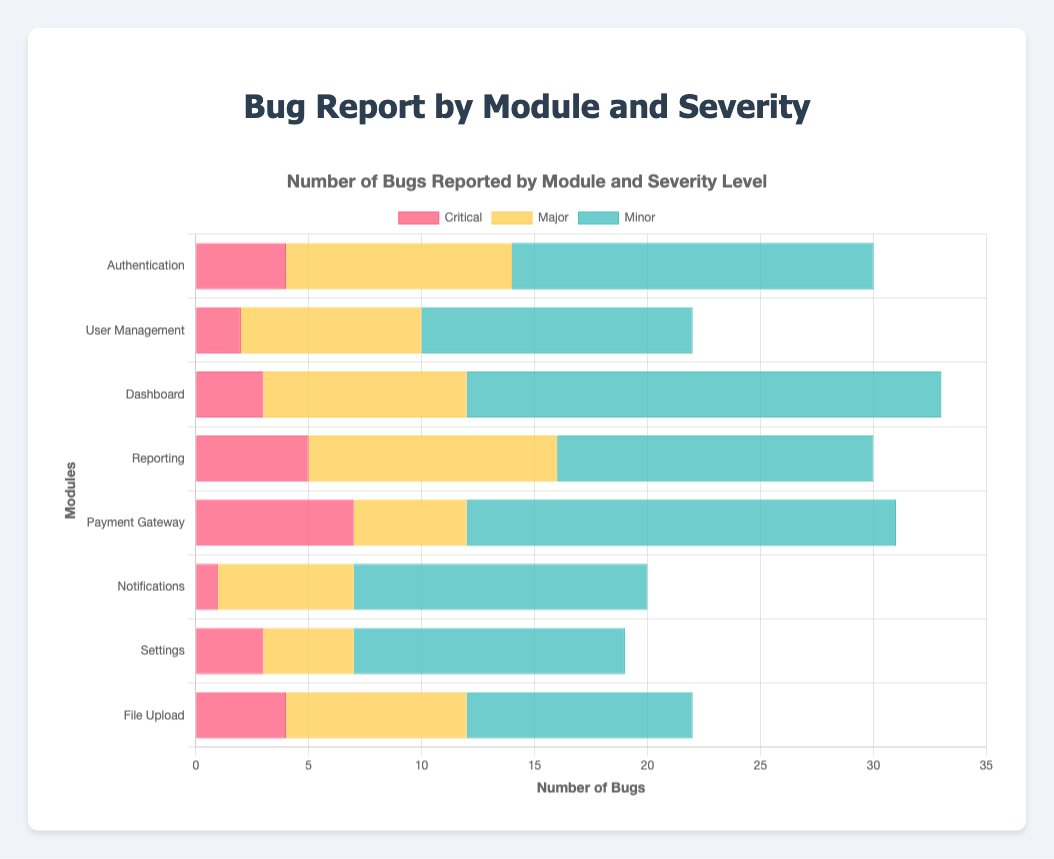What's the total number of critical bugs reported across all modules? To find the total number of critical bugs, sum up the critical bugs from all modules: 4 (Authentication) + 2 (User Management) + 3 (Dashboard) + 5 (Reporting) + 7 (Payment Gateway) + 1 (Notifications) + 3 (Settings) + 4 (File Upload) = 29
Answer: 29 Which module has the highest number of major bugs? Compare the number of major bugs across all modules: Authentication (10), User Management (8), Dashboard (9), Reporting (11), Payment Gateway (5), Notifications (6), Settings (4), File Upload (8). The Reporting module has the highest number (11).
Answer: Reporting Which severity category shows the most reported bugs in the Dashboard module? In the Dashboard module: Critical (3), Major (9), Minor (21). Among these, Minor has the most reported bugs.
Answer: Minor Which module has fewer than 10 major bugs and more than 10 minor bugs? We need to check each module against the criteria. User Management: Major (8), Minor (12); Dashboard: Major (9), Minor (21); Notifications: Major (6), Minor (13); Settings: Major (4), Minor (12). These modules meet the criteria.
Answer: User Management, Dashboard, Notifications, Settings How many total bugs are reported in the Authentication module? Sum up the bugs in the Authentication module across all severity levels: Critical (4) + Major (10) + Minor (16) = 30
Answer: 30 What's the module with the fewest critical bugs reported? Compare the critical bugs across all modules: Authentication (4), User Management (2), Dashboard (3), Reporting (5), Payment Gateway (7), Notifications (1), Settings (3), File Upload (4). The Notifications module has the fewest (1).
Answer: Notifications Which severity level in the Payment Gateway module has the largest count? In the Payment Gateway module: Critical (7), Major (5), Minor (19). Minor has the largest count.
Answer: Minor What is the average number of minor bugs reported across all modules? To find the average, sum up all minor bugs and divide by the number of modules: (16 + 12 + 21 + 14 + 19 + 13 + 12 + 10) / 8 = 117 / 8 = 14.625
Answer: 14.625 Is there any module with an equal number of major and minor bugs? Compare the numbers in each module: Authentication (Major: 10, Minor: 16), User Management (Major: 8, Minor: 12), Dashboard (Major: 9, Minor: 21), Reporting (Major: 11, Minor: 14), Payment Gateway (Major: 5, Minor: 19), Notifications (Major: 6, Minor: 13), Settings (Major: 4, Minor: 12), File Upload (Major: 8, Minor: 10). None of the modules have equal major and minor bugs.
Answer: No 